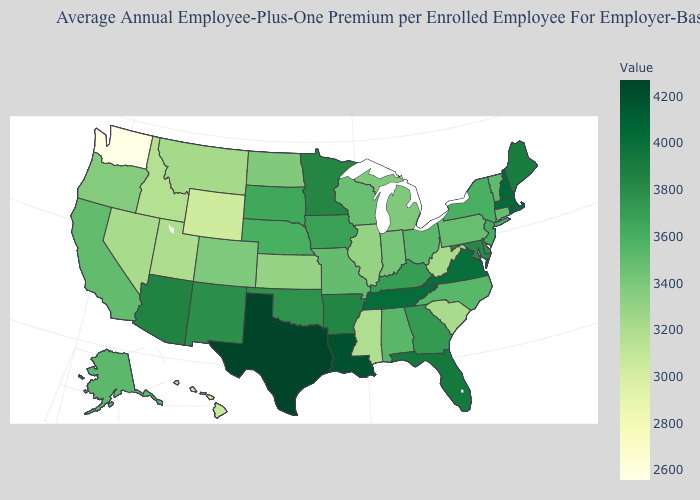Does South Carolina have a higher value than Washington?
Keep it brief. Yes. Does the map have missing data?
Be succinct. No. 